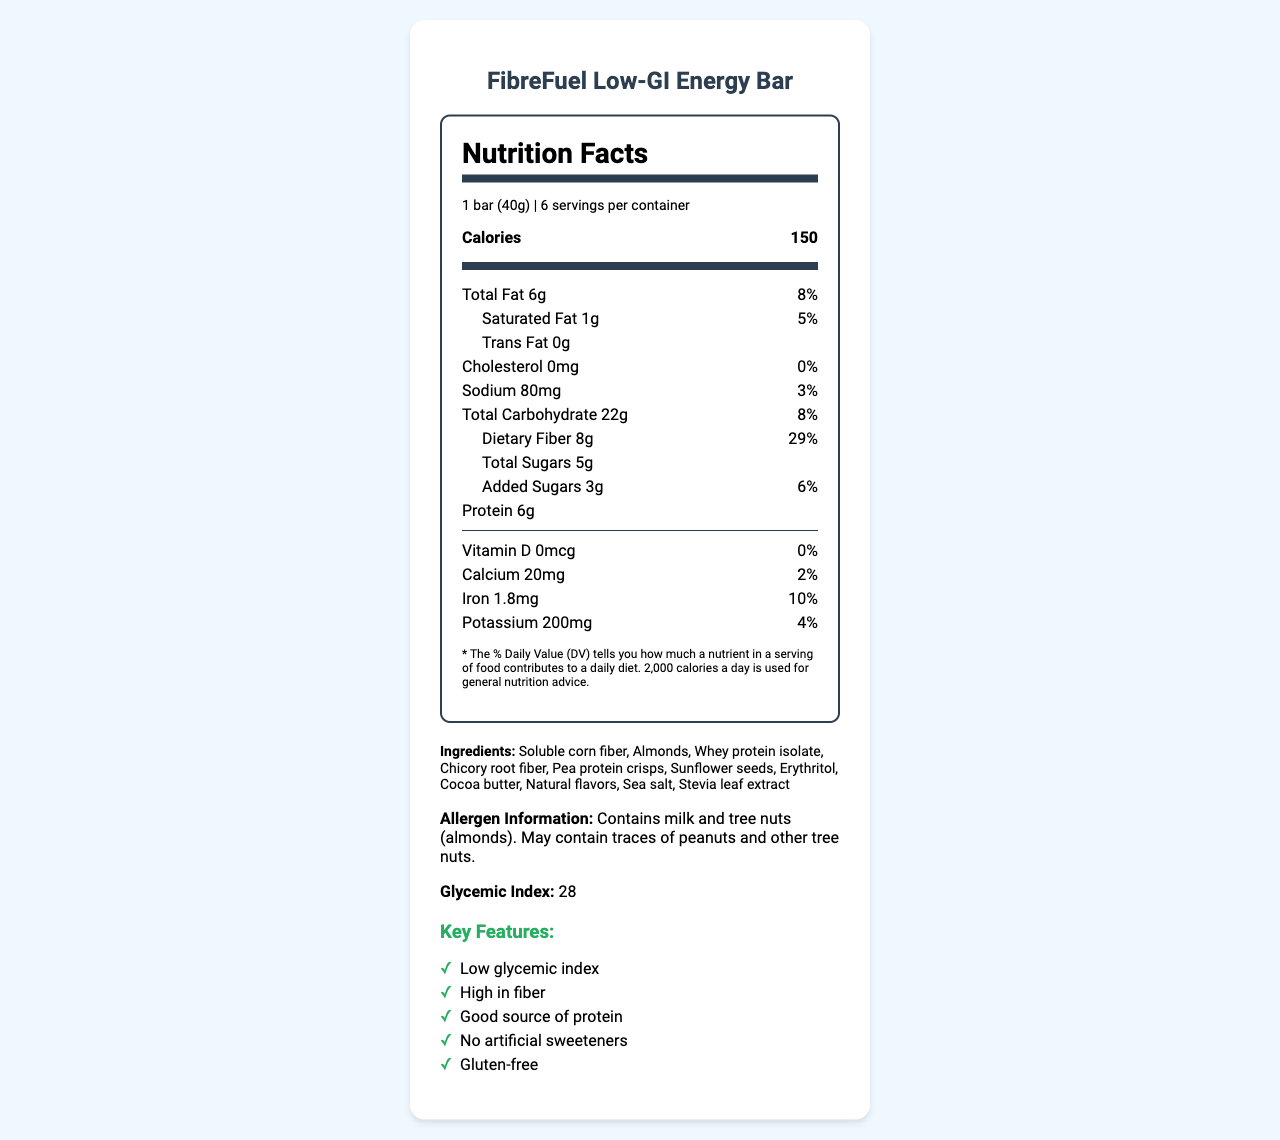what is the serving size? The serving size is prominently displayed under the product name "FibreFuel Low-GI Energy Bar".
Answer: 1 bar (40g) how many servings are in one container? Below the serving size, the label mentions that there are 6 servings per container.
Answer: 6 what is the amount of dietary fiber per serving? Under the "Total Carbohydrate" section, dietary fiber is listed as 8g.
Answer: 8g what percentage of the daily value does the dietary fiber content represent? The daily value of dietary fiber is listed as 29% next to its amount.
Answer: 29% what are the total calories from fat in one serving? The label provides the total fat amount but does not specify the calories from fat.
Answer: Cannot be determined what is the glycemic index of this snack bar? The glycemic index is explicitly stated towards the bottom section of the document.
Answer: 28 how much protein does one serving of this snack bar contain? Under the main nutrient section, protein is listed as 6g.
Answer: 6g is this product certified gluten-free? The certification section mentions "Gluten-Free Certified".
Answer: Yes how does this product support stable blood sugar levels? The low glycemic index of 28 contributes to stable blood sugar levels, as mentioned in the marketing claims.
Answer: It has a low glycemic index which nutrient has the highest percentage of the daily value? Among the listed nutrients, dietary fiber has the highest daily value percentage at 29%.
Answer: Dietary Fiber with 29% is the product free from artificial sweeteners? The key features list mentions "No artificial sweeteners".
Answer: Yes what are the primary target audiences for this product? The document lists these target audiences.
Answer: Health-conscious consumers, diabetics and pre-diabetics, fitness enthusiasts, weight watchers, busy professionals what is one marketing claim of this product related to digestive health? It is mentioned under the marketing claims.
Answer: Promotes digestive health which certifications does this product have?
I. Non-GMO Project Verified
II. Organic
III. Gluten-Free Certified
IV. Kosher
A. I, II, IV
B. II, III, IV
C. I, III, IV
D. I, II, III The product has certifications: Non-GMO Project Verified, Gluten-Free Certified, and Kosher.
Answer: C summarize the primary features and nutritional benefits of FibreFuel Low-GI Energy Bar. The summary covers the nutrition facts, key features, target audience, and various health benefits.
Answer: FibreFuel Low-GI Energy Bar is a low-glycemic index snack bar designated for health-conscious consumers, featuring high fiber content (8g per serving, 29% DV), 6g protein, no artificial sweeteners, and certifications in Non-GMO, Gluten-Free, and Kosher. It promotes stable blood sugar levels and digestive health, making it ideal for diabetics, pre-diabetics, fitness enthusiasts, and weight watchers. does this snack bar contain any allergens? The allergen information section explicitly states this.
Answer: Yes, it contains milk and tree nuts (almonds). 